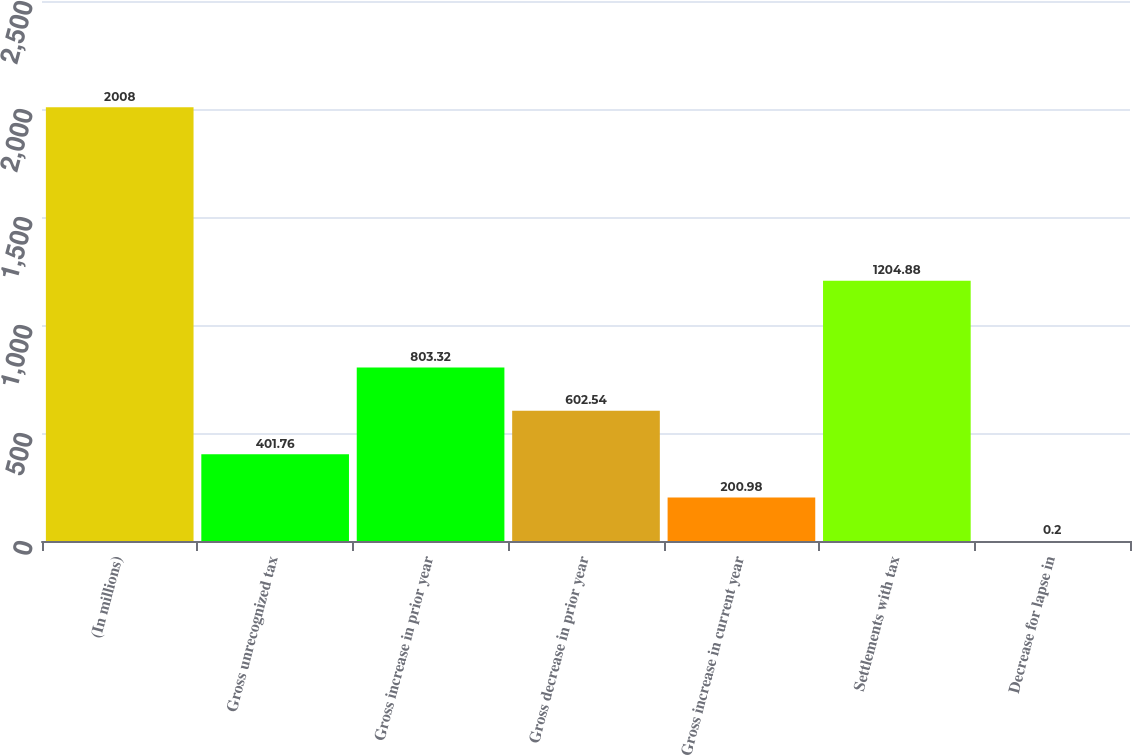<chart> <loc_0><loc_0><loc_500><loc_500><bar_chart><fcel>(In millions)<fcel>Gross unrecognized tax<fcel>Gross increase in prior year<fcel>Gross decrease in prior year<fcel>Gross increase in current year<fcel>Settlements with tax<fcel>Decrease for lapse in<nl><fcel>2008<fcel>401.76<fcel>803.32<fcel>602.54<fcel>200.98<fcel>1204.88<fcel>0.2<nl></chart> 